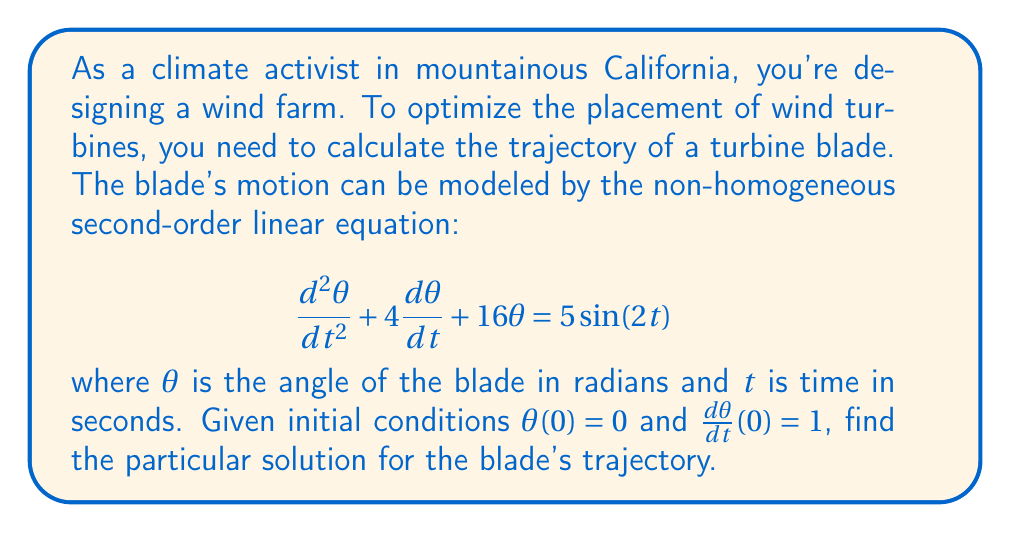Show me your answer to this math problem. To solve this non-homogeneous second-order linear equation, we'll use the method of undetermined coefficients.

1) First, we find the complementary solution $\theta_c(t)$. The characteristic equation is:
   $$r^2 + 4r + 16 = 0$$
   Solving this, we get $r = -2 \pm 2i\sqrt{3}$
   So, $\theta_c(t) = e^{-2t}(A\cos(2\sqrt{3}t) + B\sin(2\sqrt{3}t))$

2) For the particular solution $\theta_p(t)$, we assume a form:
   $$\theta_p(t) = C\cos(2t) + D\sin(2t)$$

3) Substitute this into the original equation:
   $$(-4C\cos(2t) - 4D\sin(2t)) + (4(-2C\sin(2t) + 2D\cos(2t))) + 16(C\cos(2t) + D\sin(2t)) = 5\sin(2t)$$

4) Equating coefficients:
   $$(12C + 8D)\cos(2t) + (-8C + 12D)\sin(2t) = 5\sin(2t)$$
   This gives us:
   $$12C + 8D = 0$$
   $$-8C + 12D = 5$$

5) Solving these equations:
   $$C = -\frac{5}{52}, D = \frac{15}{52}$$

6) So, the general solution is:
   $$\theta(t) = e^{-2t}(A\cos(2\sqrt{3}t) + B\sin(2\sqrt{3}t)) - \frac{5}{52}\cos(2t) + \frac{15}{52}\sin(2t)$$

7) Using the initial conditions:
   $\theta(0) = 0$ gives $A = \frac{5}{52}$
   $\frac{d\theta}{dt}(0) = 1$ gives $B = \frac{1}{2\sqrt{3}} + \frac{15}{52}$

8) Therefore, the particular solution is:
   $$\theta(t) = e^{-2t}(\frac{5}{52}\cos(2\sqrt{3}t) + (\frac{1}{2\sqrt{3}} + \frac{15}{52})\sin(2\sqrt{3}t)) - \frac{5}{52}\cos(2t) + \frac{15}{52}\sin(2t)$$
Answer: $$\theta(t) = e^{-2t}(\frac{5}{52}\cos(2\sqrt{3}t) + (\frac{1}{2\sqrt{3}} + \frac{15}{52})\sin(2\sqrt{3}t)) - \frac{5}{52}\cos(2t) + \frac{15}{52}\sin(2t)$$ 